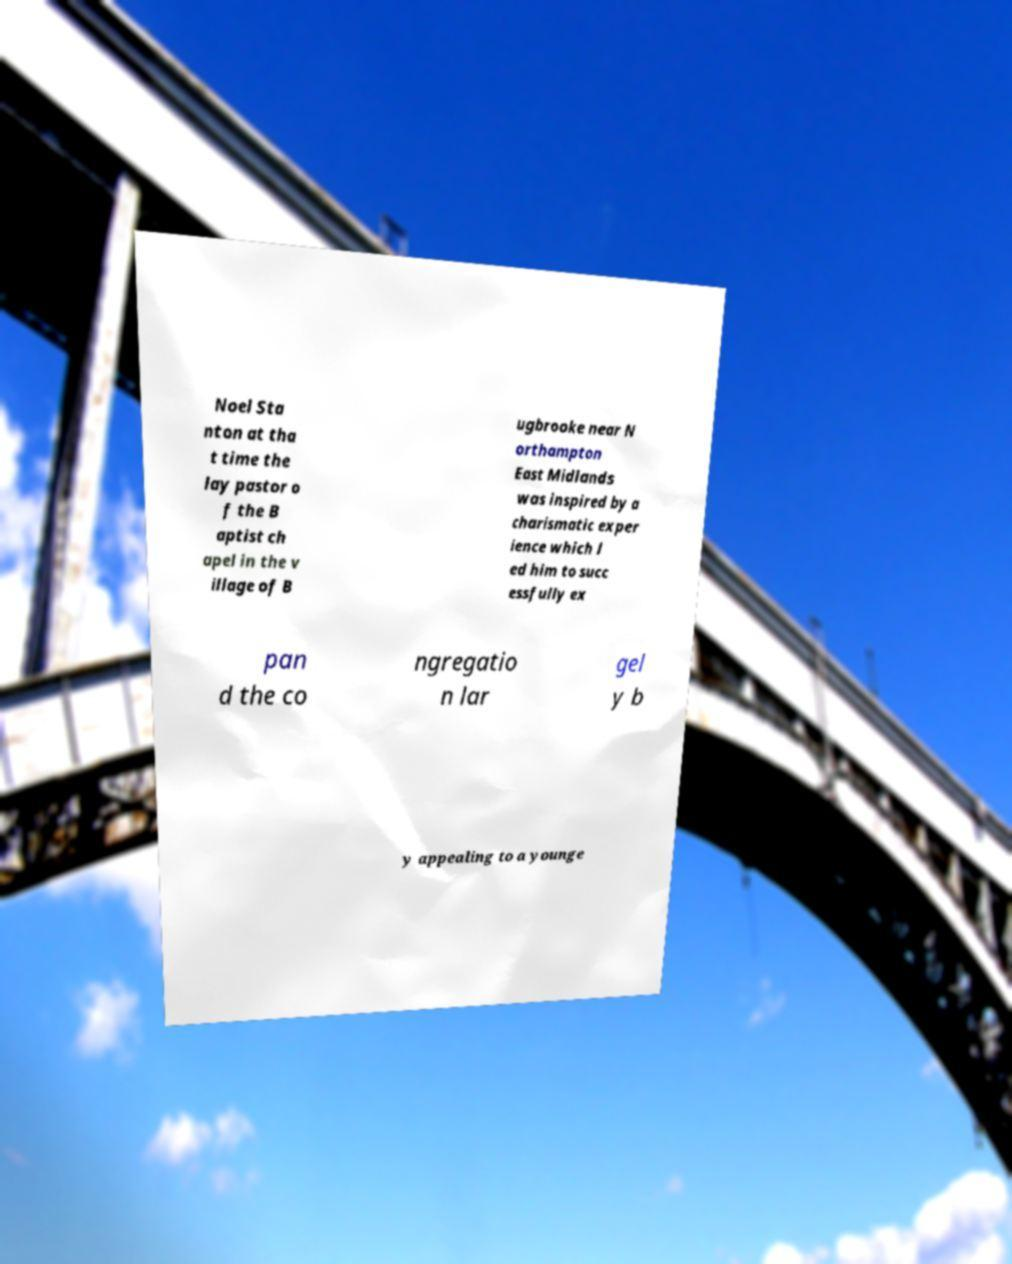Could you extract and type out the text from this image? Noel Sta nton at tha t time the lay pastor o f the B aptist ch apel in the v illage of B ugbrooke near N orthampton East Midlands was inspired by a charismatic exper ience which l ed him to succ essfully ex pan d the co ngregatio n lar gel y b y appealing to a younge 